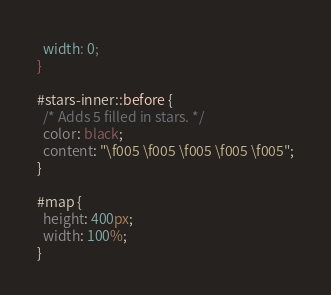Convert code to text. <code><loc_0><loc_0><loc_500><loc_500><_CSS_>  width: 0;
}

#stars-inner::before {
  /* Adds 5 filled in stars. */
  color: black;
  content: "\f005 \f005 \f005 \f005 \f005";
}

#map {
  height: 400px;
  width: 100%;
}
</code> 